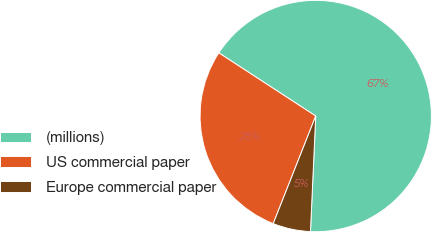<chart> <loc_0><loc_0><loc_500><loc_500><pie_chart><fcel>(millions)<fcel>US commercial paper<fcel>Europe commercial paper<nl><fcel>66.53%<fcel>28.21%<fcel>5.26%<nl></chart> 